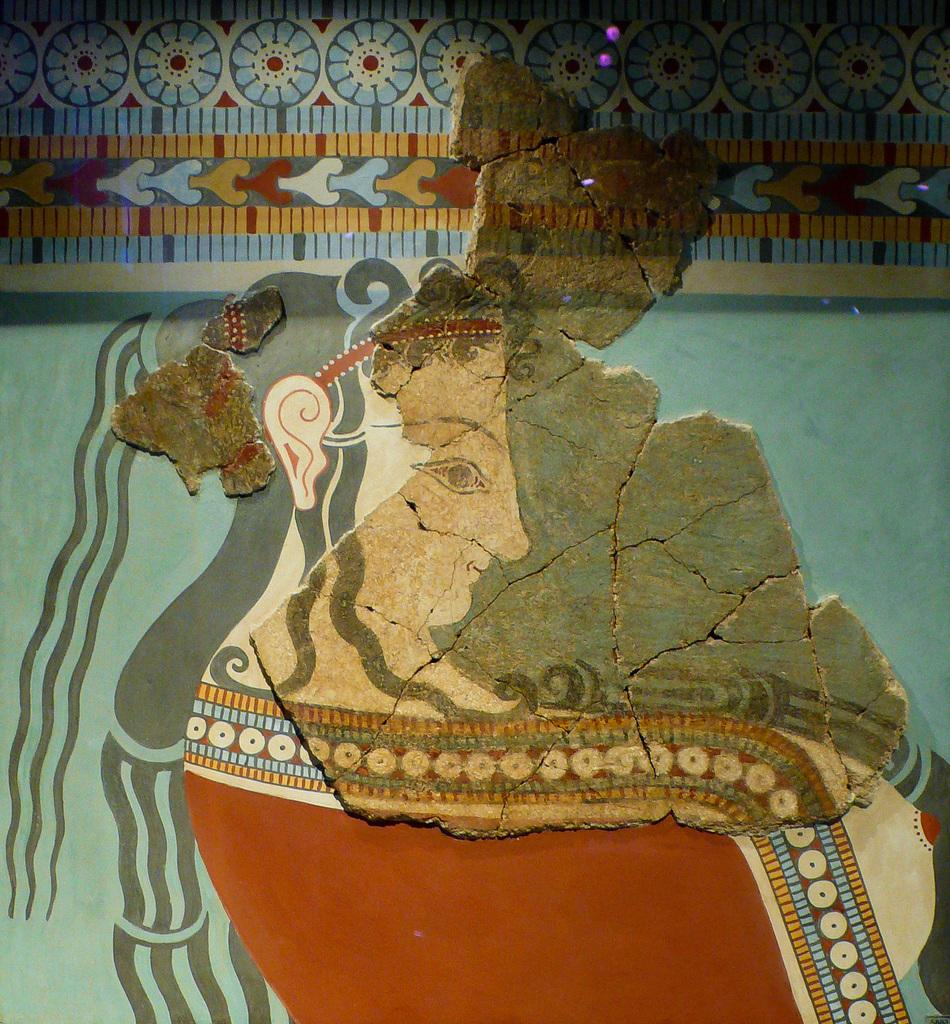What is depicted on the wall in the image? There is a painting of a woman on the wall in the image. What else can be seen on the wall above the painting? There is a design above the painting on the wall. How does the spoon help with the digestion of the minister in the image? There is no spoon, minister, or any reference to digestion in the image; it only features a painting of a woman and a design above it on the wall. 